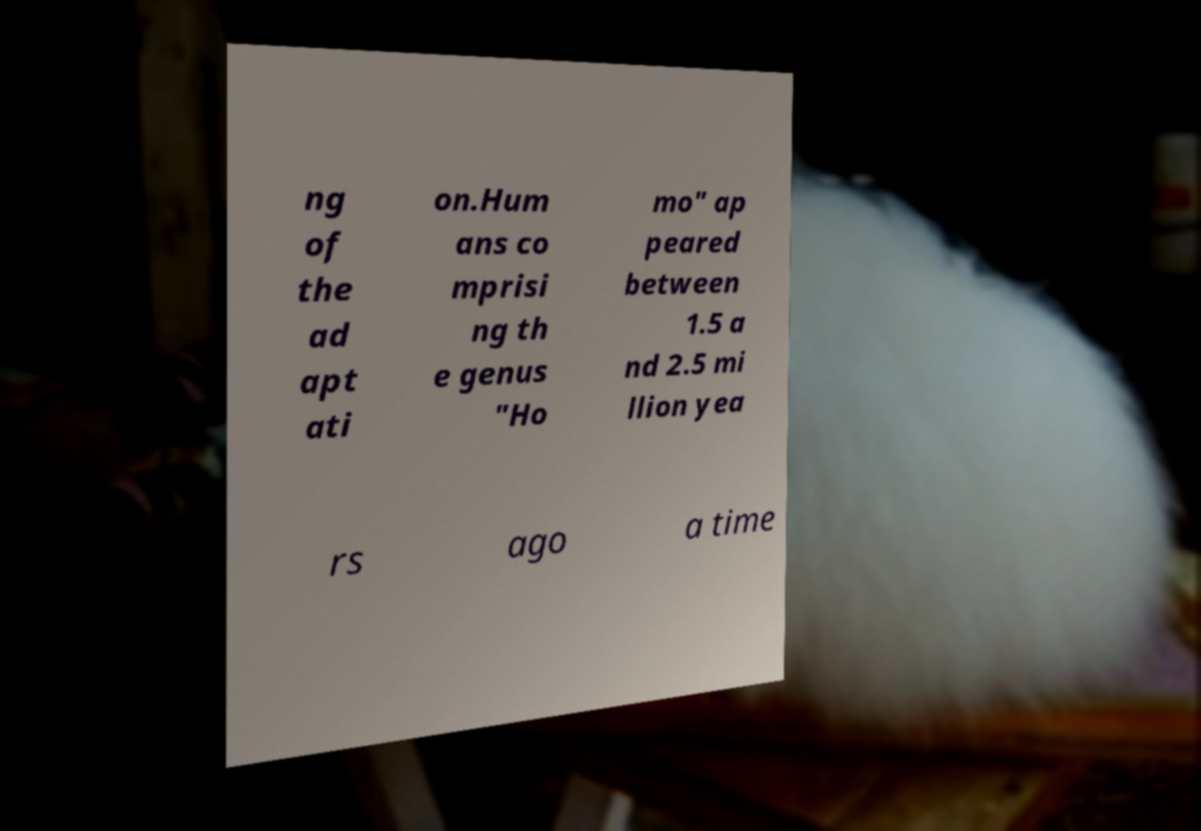Can you accurately transcribe the text from the provided image for me? ng of the ad apt ati on.Hum ans co mprisi ng th e genus "Ho mo" ap peared between 1.5 a nd 2.5 mi llion yea rs ago a time 